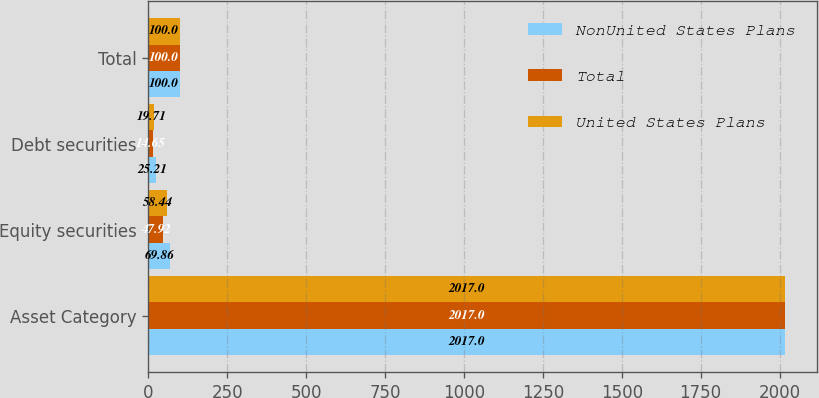<chart> <loc_0><loc_0><loc_500><loc_500><stacked_bar_chart><ecel><fcel>Asset Category<fcel>Equity securities<fcel>Debt securities<fcel>Total<nl><fcel>NonUnited States Plans<fcel>2017<fcel>69.86<fcel>25.21<fcel>100<nl><fcel>Total<fcel>2017<fcel>47.92<fcel>14.65<fcel>100<nl><fcel>United States Plans<fcel>2017<fcel>58.44<fcel>19.71<fcel>100<nl></chart> 